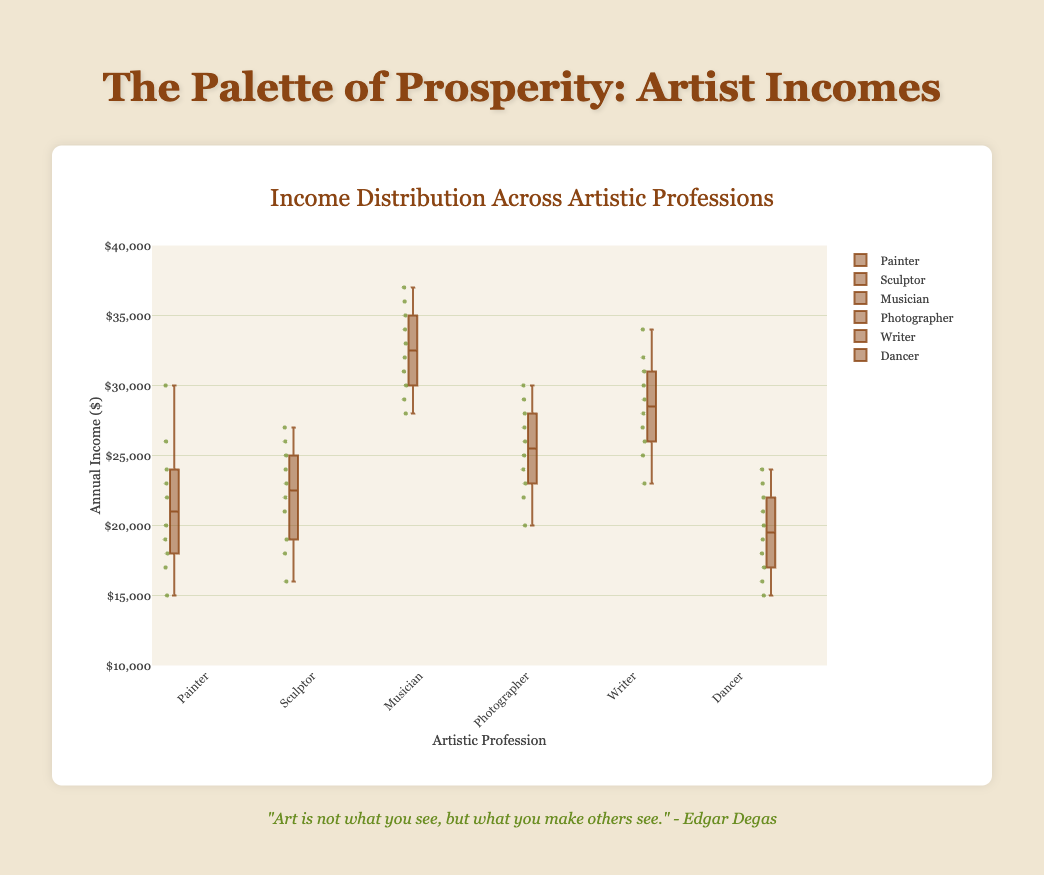what are the minimum and maximum incomes for Musicians? From the box plot, the minimum income is the bottom whisker value and the maximum income is the top whisker value for Musicians, which are $28000 and $37000 respectively
Answer: $28000 and $37000 which profession has the highest median income? The median is the line inside the box for each profession. Among all professions, the box plot for Musicians shows the highest median, which falls around $32500
Answer: Musician what is the range of incomes for Painters? The range is calculated by subtracting the minimum value (bottom whisker) from the maximum value (top whisker). For Painters, the bottom whisker is $15000 and the top whisker is $30000, so the range is $30000 - $15000
Answer: $15000 how does the median income of Writers compare to that of Photographers? To compare the medians, look at the lines in the middle of the boxes for each profession. The median for Writers is around $28500 while for Photographers it's around $25500, indicating Writers have a higher median income
Answer: Writers have higher median which professions see their upper quartile above $30000? The upper quartile is the top boundary of the box. Only Musicians and Writers have their upper quartiles above $30000 as shown by the respective positions of their upper box boundaries
Answer: Musicians and Writers what can you say about the outliers in Painters' incomes? Outliers are data points outside the whiskers. For Painters, the plot shows some points beyond the upper whisker, suggesting there are incomes higher than the majority, specifically two outliers around $26000 and $30000
Answer: Two outliers at $26000 and $30000 which profession has the smallest spread in their income distribution? The spread is the interquartile range (IQR) measured by the width of the box. Dancers have the narrowest box, indicating the smallest spread in income
Answer: Dancer 